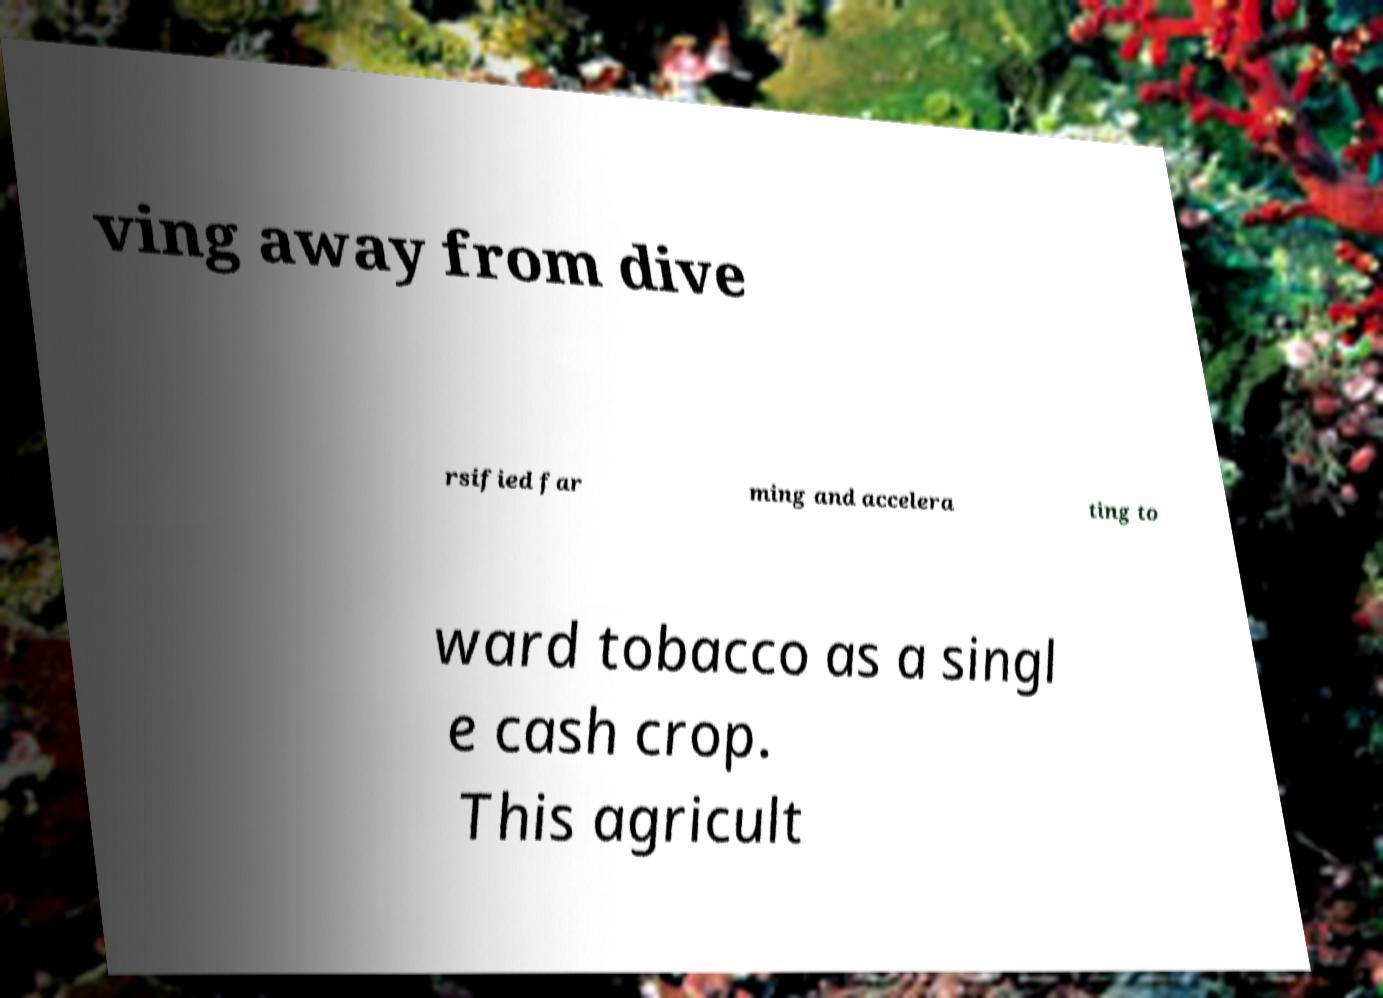Please identify and transcribe the text found in this image. ving away from dive rsified far ming and accelera ting to ward tobacco as a singl e cash crop. This agricult 